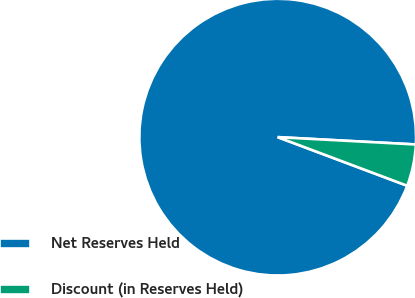Convert chart. <chart><loc_0><loc_0><loc_500><loc_500><pie_chart><fcel>Net Reserves Held<fcel>Discount (in Reserves Held)<nl><fcel>95.13%<fcel>4.87%<nl></chart> 